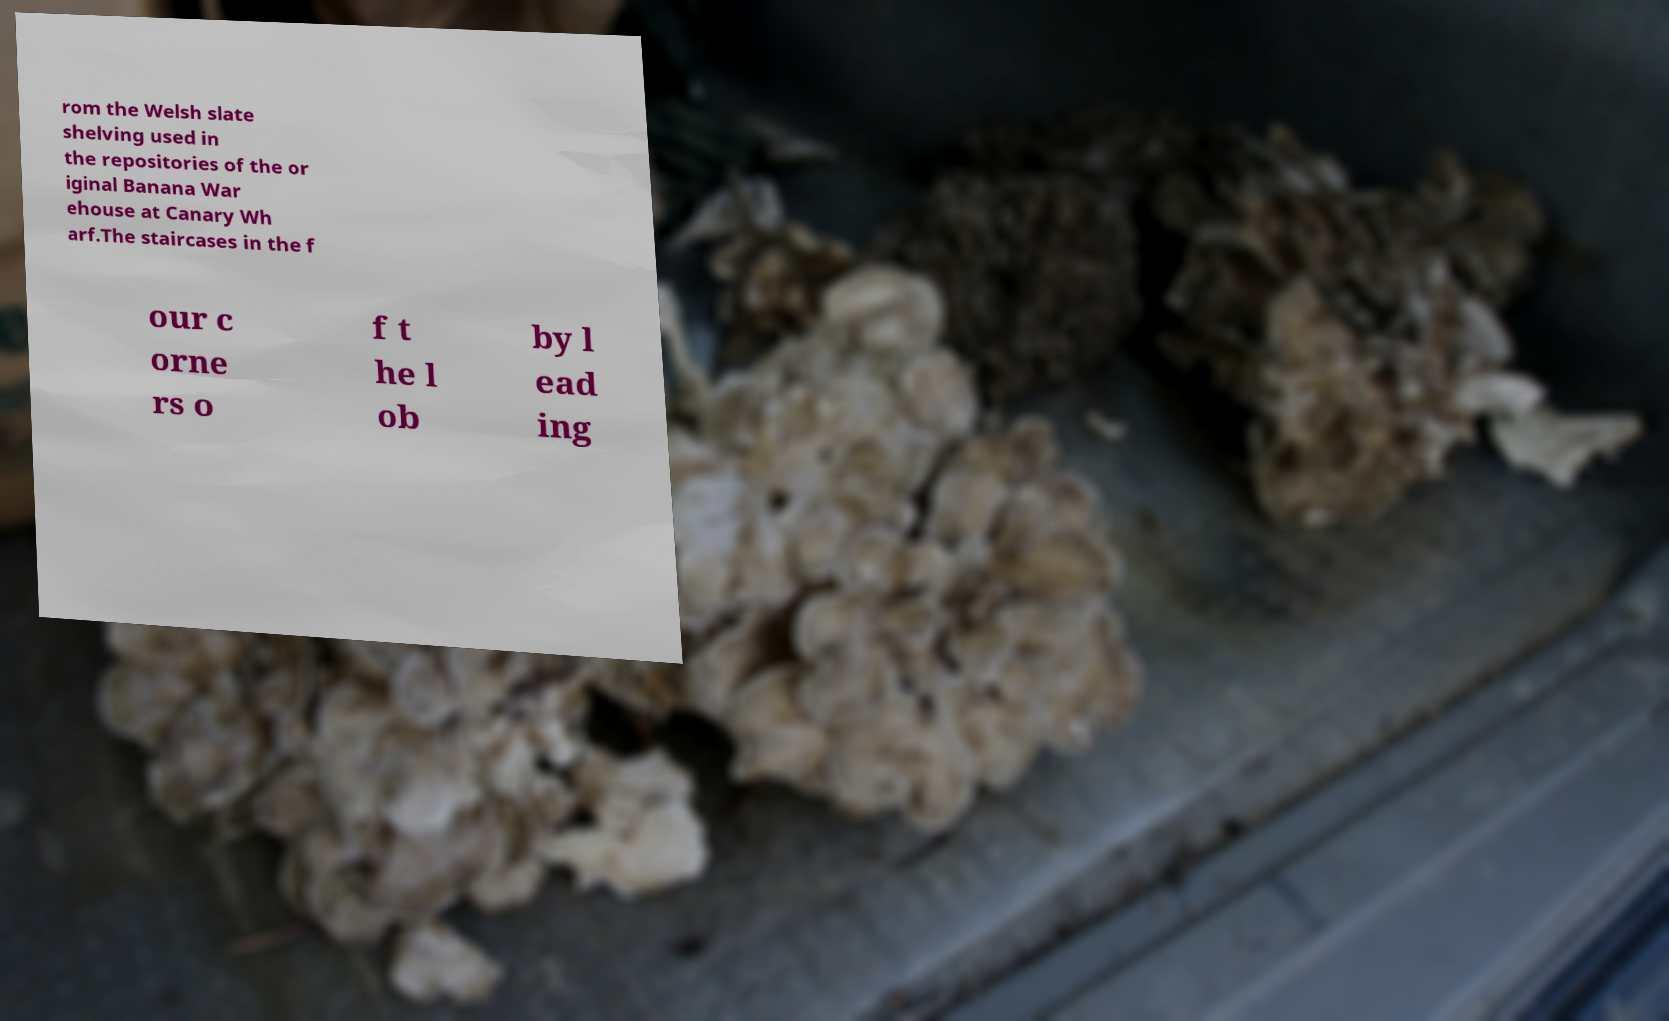Please read and relay the text visible in this image. What does it say? rom the Welsh slate shelving used in the repositories of the or iginal Banana War ehouse at Canary Wh arf.The staircases in the f our c orne rs o f t he l ob by l ead ing 